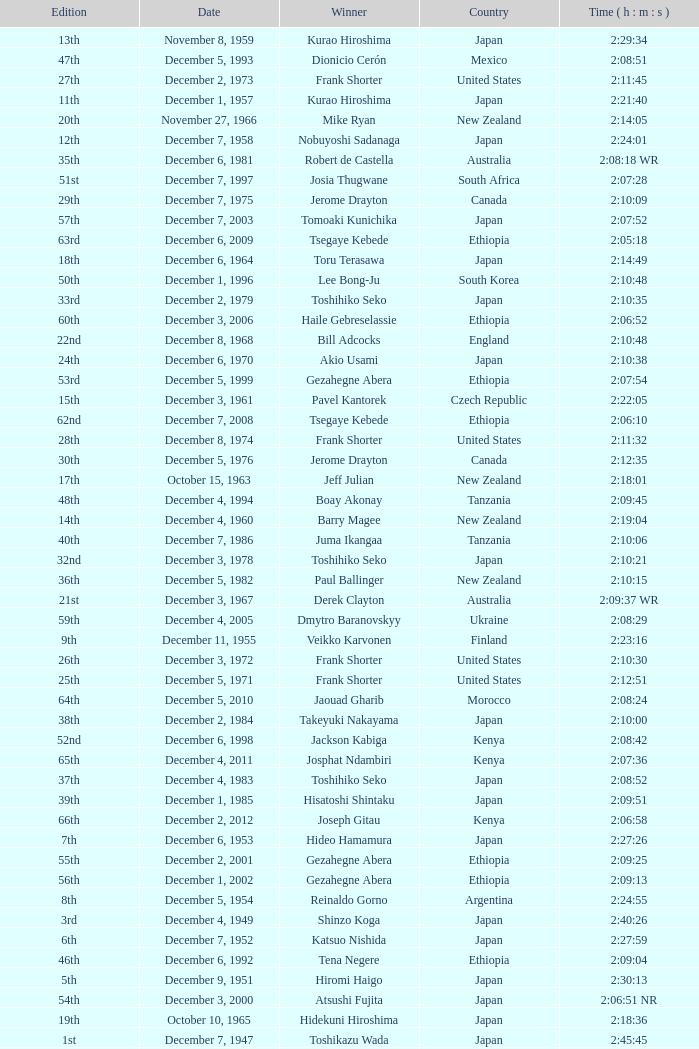What was the nationality of the winner for the 20th Edition? New Zealand. 